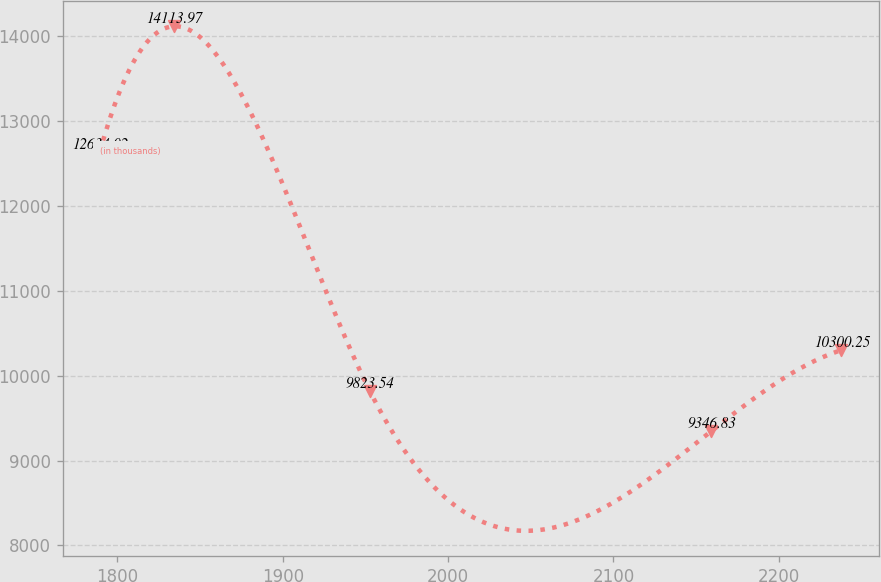Convert chart. <chart><loc_0><loc_0><loc_500><loc_500><line_chart><ecel><fcel>(in thousands)<nl><fcel>1789.29<fcel>12634<nl><fcel>1834.15<fcel>14114<nl><fcel>1952.5<fcel>9823.54<nl><fcel>2159.19<fcel>9346.83<nl><fcel>2237.87<fcel>10300.2<nl></chart> 